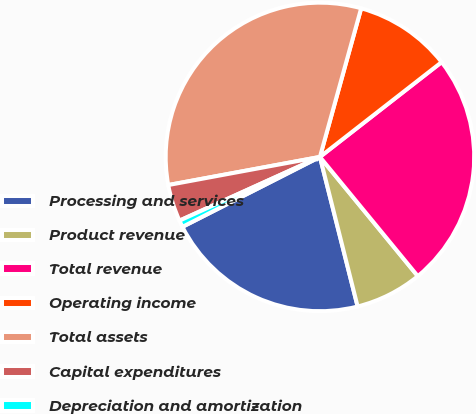Convert chart to OTSL. <chart><loc_0><loc_0><loc_500><loc_500><pie_chart><fcel>Processing and services<fcel>Product revenue<fcel>Total revenue<fcel>Operating income<fcel>Total assets<fcel>Capital expenditures<fcel>Depreciation and amortization<nl><fcel>21.44%<fcel>7.01%<fcel>24.59%<fcel>10.16%<fcel>32.22%<fcel>3.86%<fcel>0.71%<nl></chart> 